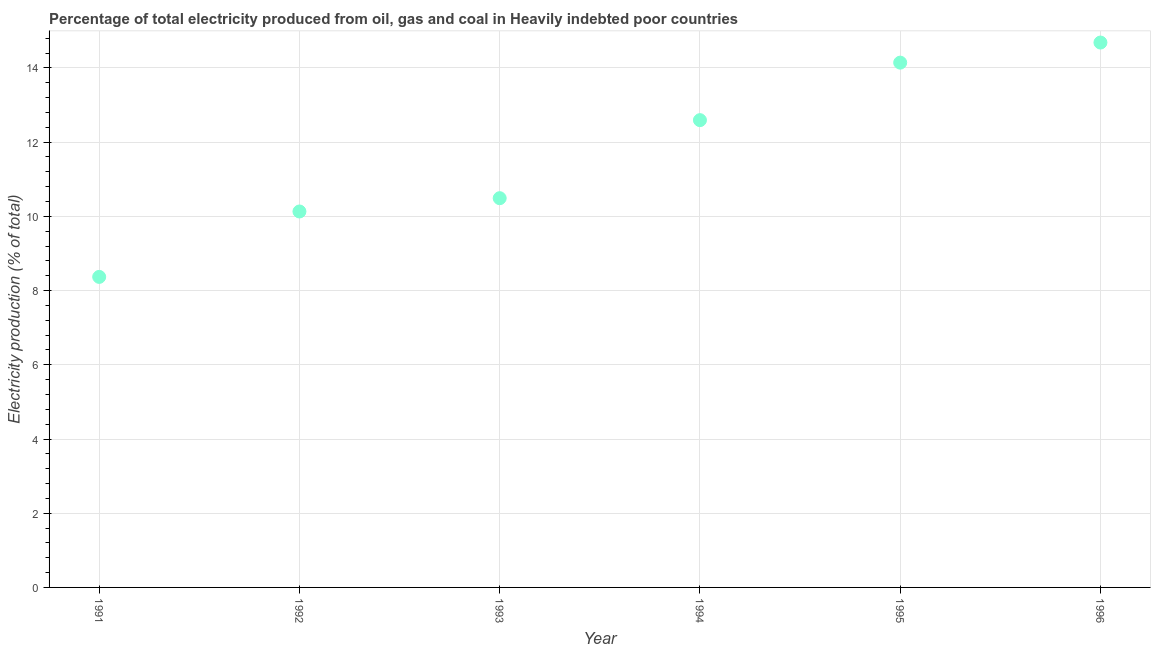What is the electricity production in 1994?
Ensure brevity in your answer.  12.59. Across all years, what is the maximum electricity production?
Provide a short and direct response. 14.68. Across all years, what is the minimum electricity production?
Ensure brevity in your answer.  8.37. In which year was the electricity production maximum?
Your answer should be very brief. 1996. In which year was the electricity production minimum?
Provide a succinct answer. 1991. What is the sum of the electricity production?
Ensure brevity in your answer.  70.41. What is the difference between the electricity production in 1991 and 1993?
Your response must be concise. -2.12. What is the average electricity production per year?
Offer a very short reply. 11.73. What is the median electricity production?
Provide a short and direct response. 11.54. In how many years, is the electricity production greater than 7.2 %?
Ensure brevity in your answer.  6. What is the ratio of the electricity production in 1993 to that in 1994?
Make the answer very short. 0.83. Is the electricity production in 1995 less than that in 1996?
Ensure brevity in your answer.  Yes. What is the difference between the highest and the second highest electricity production?
Your response must be concise. 0.54. Is the sum of the electricity production in 1992 and 1996 greater than the maximum electricity production across all years?
Your answer should be very brief. Yes. What is the difference between the highest and the lowest electricity production?
Ensure brevity in your answer.  6.32. Does the electricity production monotonically increase over the years?
Your answer should be compact. Yes. How many dotlines are there?
Offer a terse response. 1. What is the difference between two consecutive major ticks on the Y-axis?
Ensure brevity in your answer.  2. Are the values on the major ticks of Y-axis written in scientific E-notation?
Offer a terse response. No. Does the graph contain any zero values?
Your answer should be compact. No. Does the graph contain grids?
Provide a succinct answer. Yes. What is the title of the graph?
Your answer should be very brief. Percentage of total electricity produced from oil, gas and coal in Heavily indebted poor countries. What is the label or title of the Y-axis?
Ensure brevity in your answer.  Electricity production (% of total). What is the Electricity production (% of total) in 1991?
Ensure brevity in your answer.  8.37. What is the Electricity production (% of total) in 1992?
Keep it short and to the point. 10.13. What is the Electricity production (% of total) in 1993?
Ensure brevity in your answer.  10.49. What is the Electricity production (% of total) in 1994?
Ensure brevity in your answer.  12.59. What is the Electricity production (% of total) in 1995?
Ensure brevity in your answer.  14.14. What is the Electricity production (% of total) in 1996?
Your answer should be compact. 14.68. What is the difference between the Electricity production (% of total) in 1991 and 1992?
Make the answer very short. -1.76. What is the difference between the Electricity production (% of total) in 1991 and 1993?
Ensure brevity in your answer.  -2.12. What is the difference between the Electricity production (% of total) in 1991 and 1994?
Your response must be concise. -4.22. What is the difference between the Electricity production (% of total) in 1991 and 1995?
Provide a succinct answer. -5.77. What is the difference between the Electricity production (% of total) in 1991 and 1996?
Provide a short and direct response. -6.32. What is the difference between the Electricity production (% of total) in 1992 and 1993?
Your answer should be compact. -0.36. What is the difference between the Electricity production (% of total) in 1992 and 1994?
Offer a very short reply. -2.46. What is the difference between the Electricity production (% of total) in 1992 and 1995?
Offer a very short reply. -4.01. What is the difference between the Electricity production (% of total) in 1992 and 1996?
Keep it short and to the point. -4.55. What is the difference between the Electricity production (% of total) in 1993 and 1994?
Your response must be concise. -2.1. What is the difference between the Electricity production (% of total) in 1993 and 1995?
Your response must be concise. -3.65. What is the difference between the Electricity production (% of total) in 1993 and 1996?
Your answer should be very brief. -4.19. What is the difference between the Electricity production (% of total) in 1994 and 1995?
Provide a succinct answer. -1.55. What is the difference between the Electricity production (% of total) in 1994 and 1996?
Provide a succinct answer. -2.09. What is the difference between the Electricity production (% of total) in 1995 and 1996?
Offer a terse response. -0.54. What is the ratio of the Electricity production (% of total) in 1991 to that in 1992?
Offer a terse response. 0.83. What is the ratio of the Electricity production (% of total) in 1991 to that in 1993?
Provide a succinct answer. 0.8. What is the ratio of the Electricity production (% of total) in 1991 to that in 1994?
Offer a terse response. 0.67. What is the ratio of the Electricity production (% of total) in 1991 to that in 1995?
Keep it short and to the point. 0.59. What is the ratio of the Electricity production (% of total) in 1991 to that in 1996?
Your answer should be compact. 0.57. What is the ratio of the Electricity production (% of total) in 1992 to that in 1993?
Your answer should be very brief. 0.97. What is the ratio of the Electricity production (% of total) in 1992 to that in 1994?
Your answer should be compact. 0.81. What is the ratio of the Electricity production (% of total) in 1992 to that in 1995?
Your answer should be very brief. 0.72. What is the ratio of the Electricity production (% of total) in 1992 to that in 1996?
Make the answer very short. 0.69. What is the ratio of the Electricity production (% of total) in 1993 to that in 1994?
Your answer should be compact. 0.83. What is the ratio of the Electricity production (% of total) in 1993 to that in 1995?
Give a very brief answer. 0.74. What is the ratio of the Electricity production (% of total) in 1993 to that in 1996?
Your answer should be very brief. 0.71. What is the ratio of the Electricity production (% of total) in 1994 to that in 1995?
Keep it short and to the point. 0.89. What is the ratio of the Electricity production (% of total) in 1994 to that in 1996?
Offer a terse response. 0.86. What is the ratio of the Electricity production (% of total) in 1995 to that in 1996?
Keep it short and to the point. 0.96. 